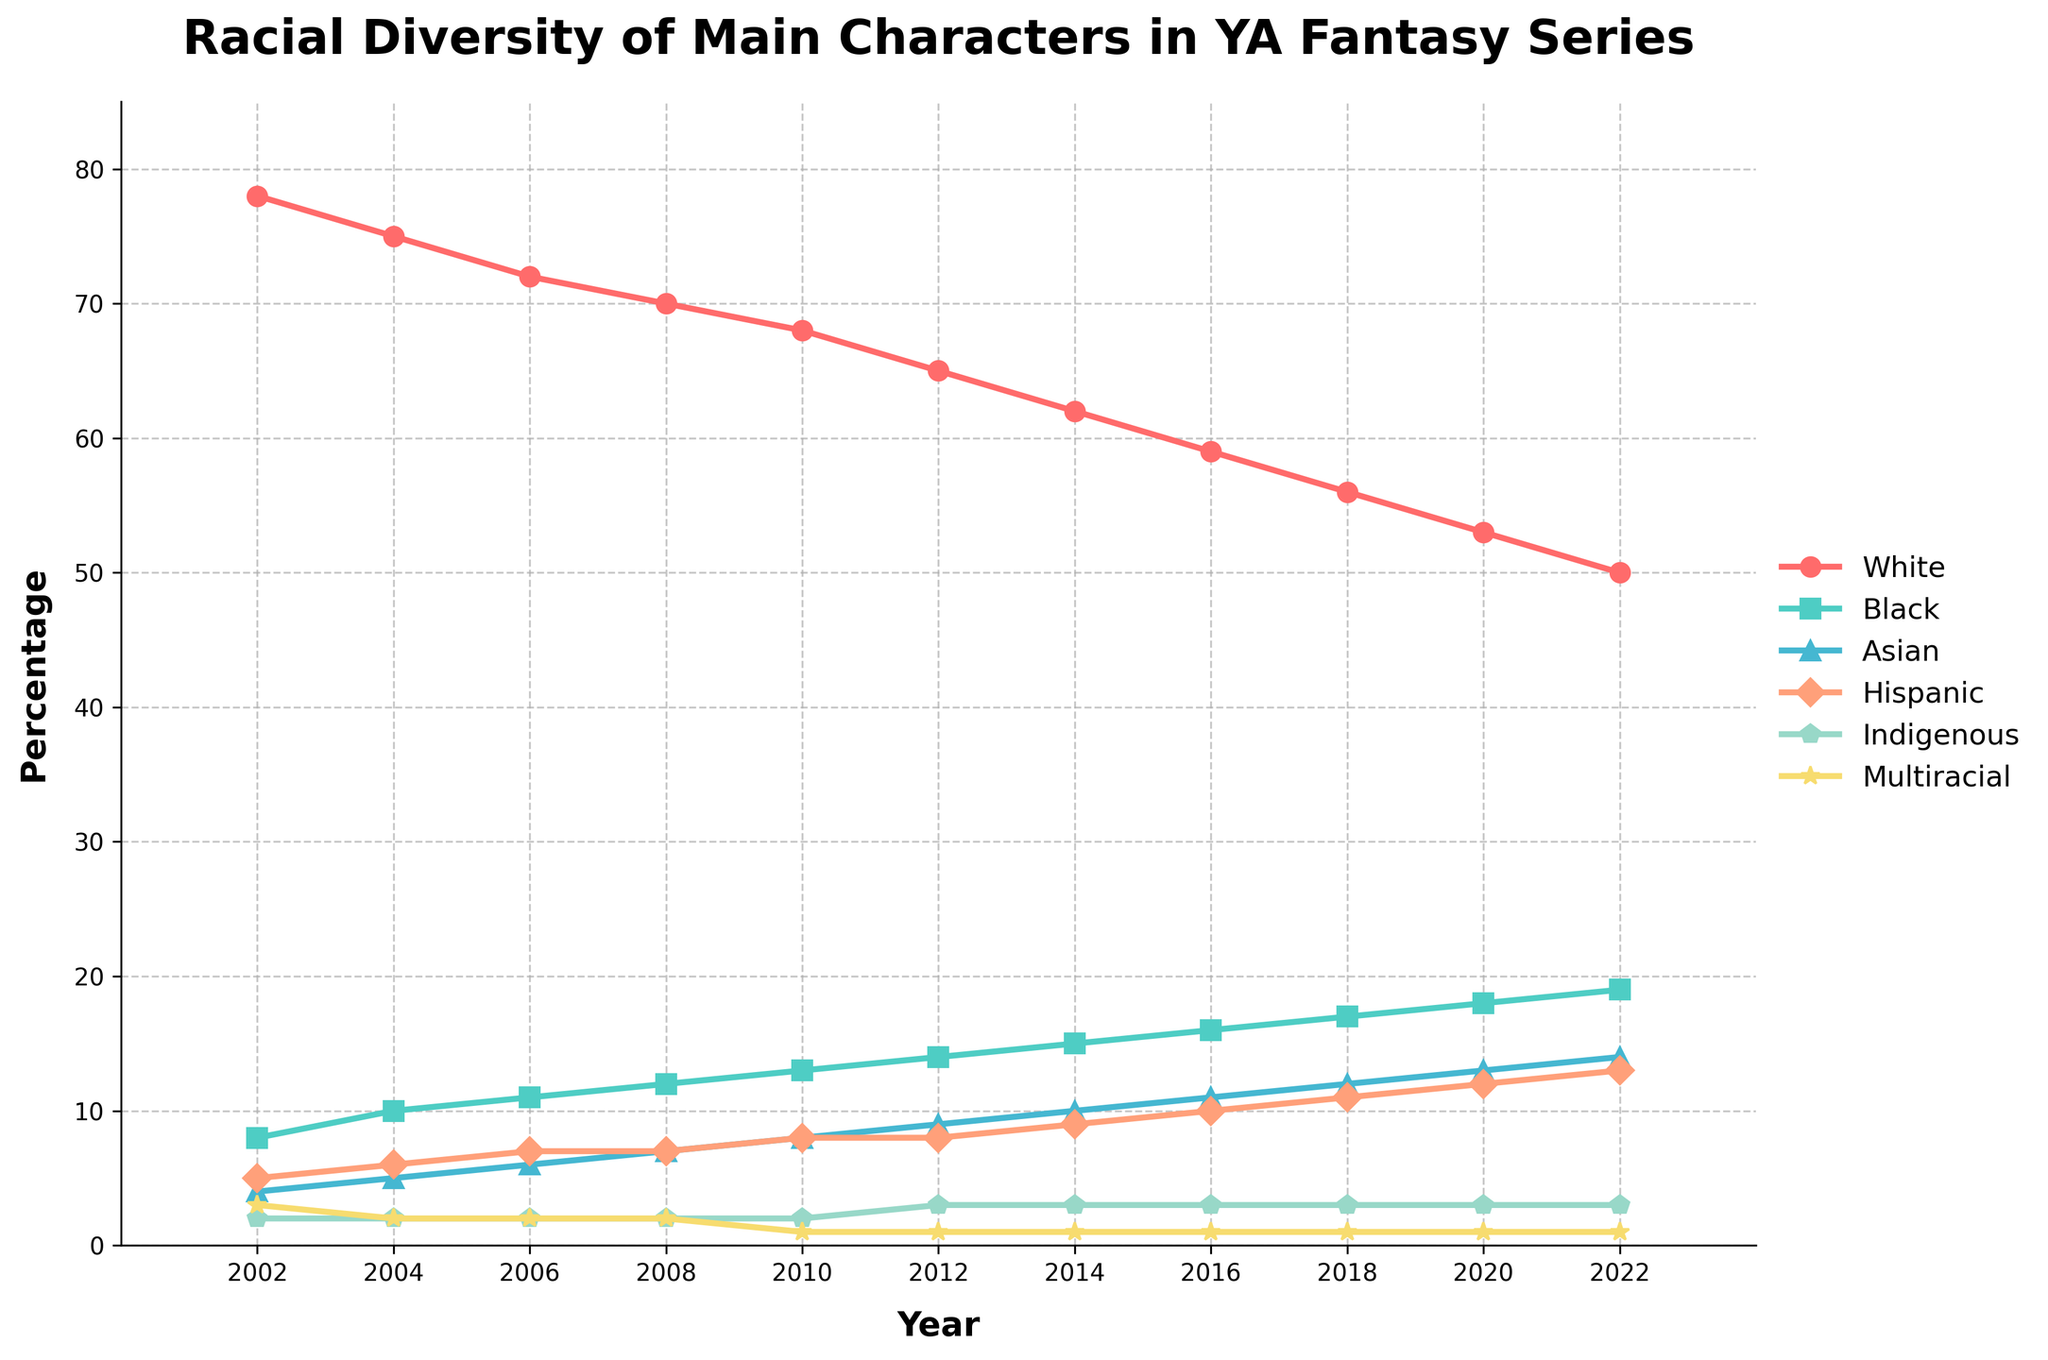What's the trend for the percentage of White main characters over the two decades? The percentage of White main characters decreases from 78% in 2002 to 50% in 2022, showing a downward trend.
Answer: Downward Comparing the year 2014 and 2018, which ethnic group showed the biggest increase in percentage? From the figure, the percentage of Black main characters increased from 15% in 2014 to 17% in 2018, a 2% increase, which is the biggest increase among all groups during that period.
Answer: Black In which year did the percentage of Hispanic main characters first reach 10%? The line for Hispanic main characters first reaches the 10% mark in 2014.
Answer: 2014 How have the percentages of Indigenous and Multiracial main characters changed over the two decades? The percentage of Indigenous characters remained constant at 2-3%, while Multiracial characters decreased slightly from 3% to 1%.
Answer: Indigenous: constant, Multiracial: slightly decreased What is the total increase in the percentage of Asian main characters from 2002 to 2022? The percentage of Asian main characters increased from 4% in 2002 to 14% in 2022, an increase of 10%.
Answer: 10% Which group had the smallest percentage change from 2002 to 2022? The visual comparison shows that Multiracial main characters had the smallest change, decreasing from 3% to 1%, a change of 2%.
Answer: Multiracial How did the percentage of Black main characters change between 2010 and 2020? The percentage of Black main characters increased from 13% in 2010 to 18% in 2020, a 5% increase.
Answer: Increased by 5% What is the trend in the percentage of Hispanic main characters from 2002 to 2022? The trend shows a steady increase from 5% in 2002 to 13% in 2022.
Answer: Steady increase By how much did the percentage of White main characters decrease from 2016 to 2022? The percentage of White main characters decreased from 59% in 2016 to 50% in 2022, a decrease of 9%.
Answer: Decreased by 9% Which ethnic group showed the greatest overall increase in representation from 2002 to 2022? The Black main characters showed the greatest overall increase, rising from 8% in 2002 to 19% in 2022, an 11% increase.
Answer: Black 